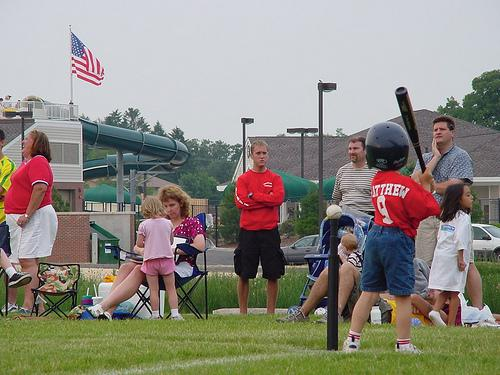Question: what game is being played?
Choices:
A. T-ball.
B. Soccer.
C. Football.
D. Jump rope.
Answer with the letter. Answer: A Question: why does the boy wear a helmet?
Choices:
A. For fashion.
B. To have fun.
C. To avoid injury.
D. To be part of group.
Answer with the letter. Answer: C Question: where is this taking place?
Choices:
A. Park.
B. Beach.
C. A sports field.
D. Airport.
Answer with the letter. Answer: C 